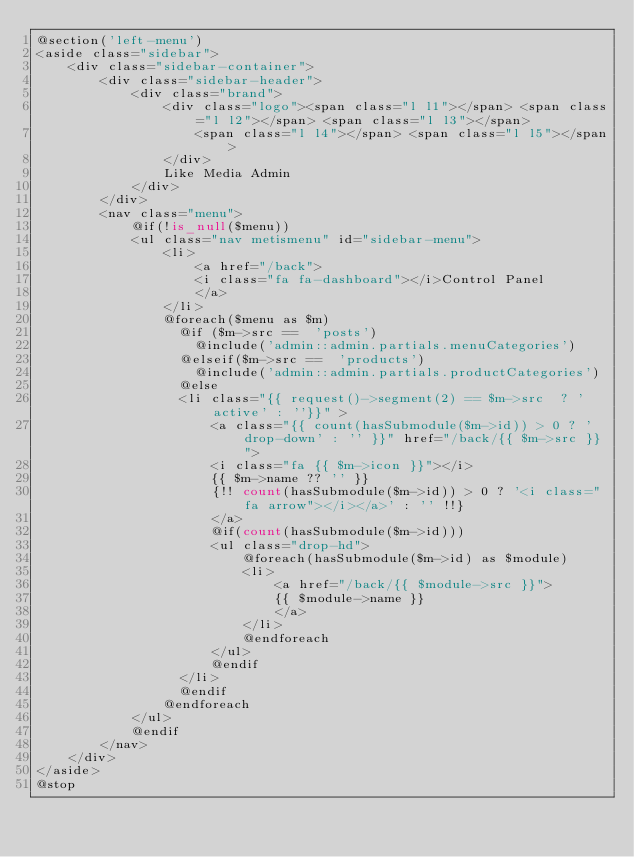Convert code to text. <code><loc_0><loc_0><loc_500><loc_500><_PHP_>@section('left-menu')
<aside class="sidebar">
    <div class="sidebar-container">
        <div class="sidebar-header">
            <div class="brand">
                <div class="logo"><span class="l l1"></span> <span class="l l2"></span> <span class="l l3"></span>
                    <span class="l l4"></span> <span class="l l5"></span>
                </div>
                Like Media Admin
            </div>
        </div>
        <nav class="menu">
            @if(!is_null($menu))
            <ul class="nav metismenu" id="sidebar-menu">
                <li>
                    <a href="/back">
                    <i class="fa fa-dashboard"></i>Control Panel
                    </a>
                </li>
                @foreach($menu as $m)
                  @if ($m->src ==  'posts')
                    @include('admin::admin.partials.menuCategories')
                  @elseif($m->src ==  'products')
                    @include('admin::admin.partials.productCategories')
                  @else
                  <li class="{{ request()->segment(2) == $m->src  ? 'active' : ''}}" >
                      <a class="{{ count(hasSubmodule($m->id)) > 0 ? 'drop-down' : '' }}" href="/back/{{ $m->src }}">
                      <i class="fa {{ $m->icon }}"></i>
                      {{ $m->name ?? '' }}
                      {!! count(hasSubmodule($m->id)) > 0 ? '<i class="fa arrow"></i></a>' : '' !!}
                      </a>
                      @if(count(hasSubmodule($m->id)))
                      <ul class="drop-hd">
                          @foreach(hasSubmodule($m->id) as $module)
                          <li>
                              <a href="/back/{{ $module->src }}">
                              {{ $module->name }}
                              </a>
                          </li>
                          @endforeach
                      </ul>
                      @endif
                  </li>
                  @endif
                @endforeach
            </ul>
            @endif
        </nav>
    </div>
</aside>
@stop
</code> 